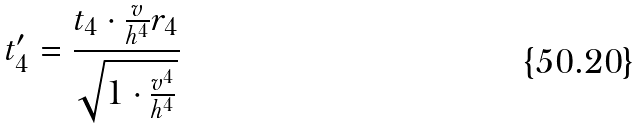<formula> <loc_0><loc_0><loc_500><loc_500>t _ { 4 } ^ { \prime } = \frac { t _ { 4 } \cdot \frac { v } { h ^ { 4 } } r _ { 4 } } { \sqrt { 1 \cdot \frac { v ^ { 4 } } { h ^ { 4 } } } }</formula> 